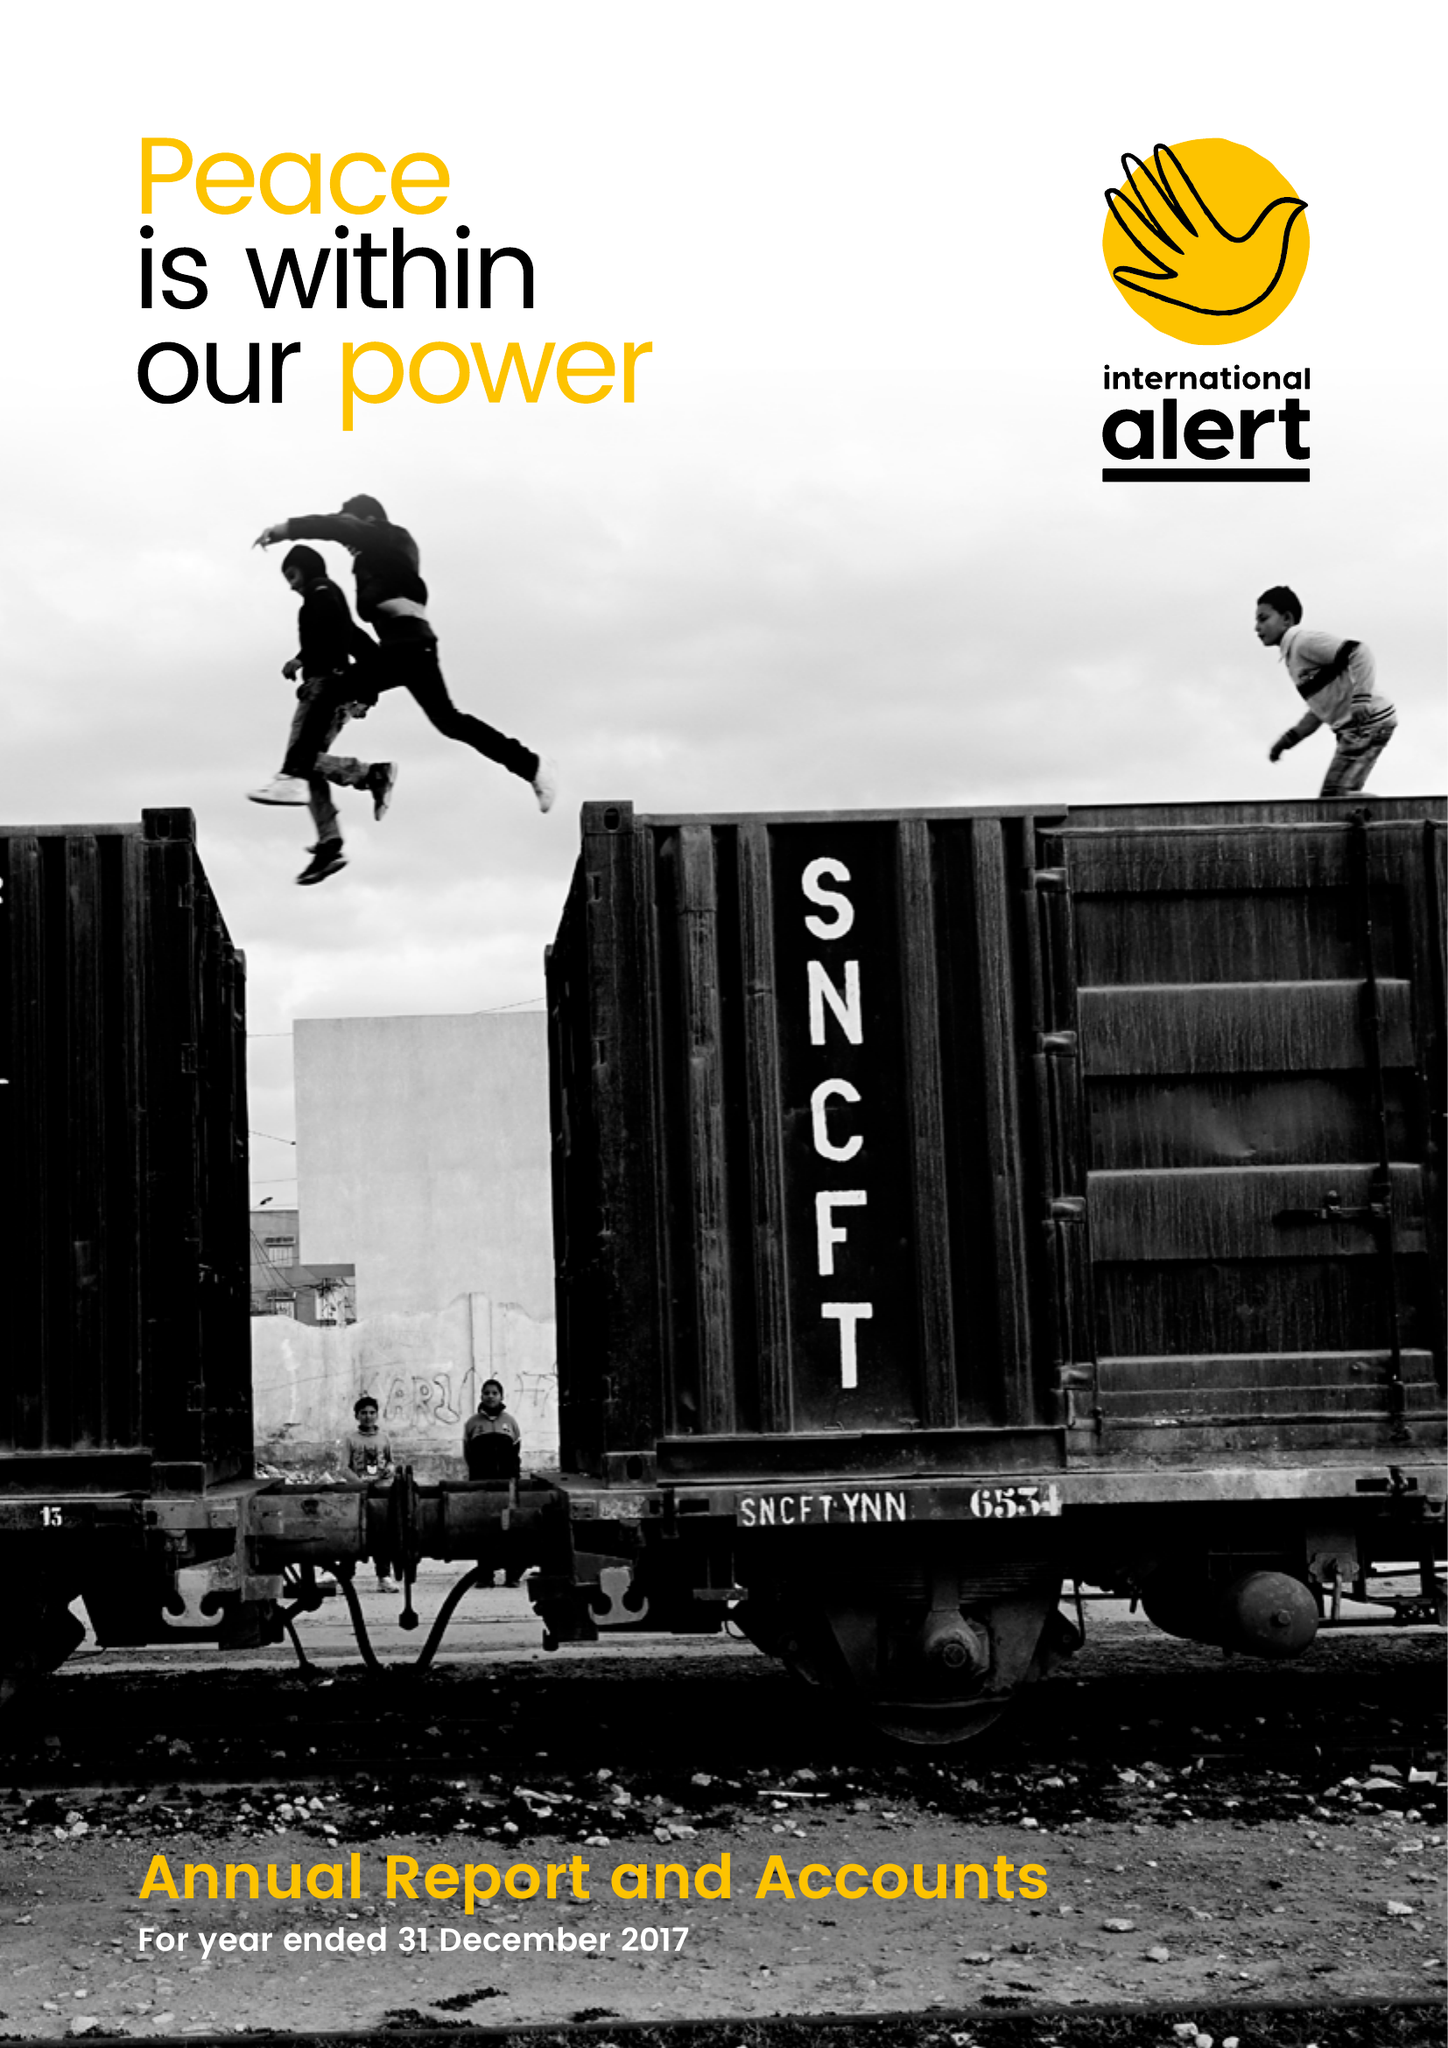What is the value for the spending_annually_in_british_pounds?
Answer the question using a single word or phrase. 17215000.00 